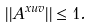<formula> <loc_0><loc_0><loc_500><loc_500>| | A ^ { x u v } | | \leq 1 .</formula> 